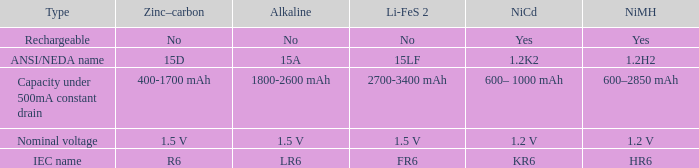What is NiCd, when Type is "Capacity under 500mA constant Drain"? 600– 1000 mAh. 